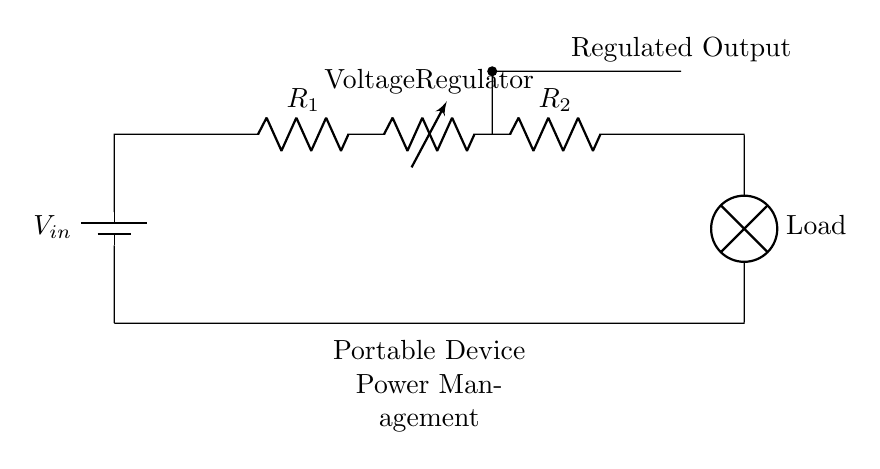What type of circuit is represented in the diagram? The circuit is a series circuit since all components are connected end-to-end, forming a single path for current flow.
Answer: Series circuit What is the purpose of the voltage regulator in the circuit? The voltage regulator ensures a stable output voltage for the connected load despite variations in the input voltage or load conditions.
Answer: Stabilize output voltage What component is used to limit current in the circuit? The resistor labeled R1 is used to limit current flow in the circuit, providing protection and controlling the voltage drop across components.
Answer: R1 How many resistors are in the circuit? There are two resistors in the circuit, which are labeled as R1 and R2.
Answer: Two What is this circuit designed for? The circuit is designed for portable device power management, indicated by the description at the bottom of the diagram.
Answer: Portable device power management Which component directly supplies power to the load? The battery, labeled as Vin, directly supplies power to the load by providing the necessary voltage for operation.
Answer: Battery If the input voltage is 9V, what is the characteristic of the output from the regulator? The output from the regulator will be a regulated voltage, maintaining a constant level suitable for the load, regardless of variations in the input or load.
Answer: Regulated voltage 